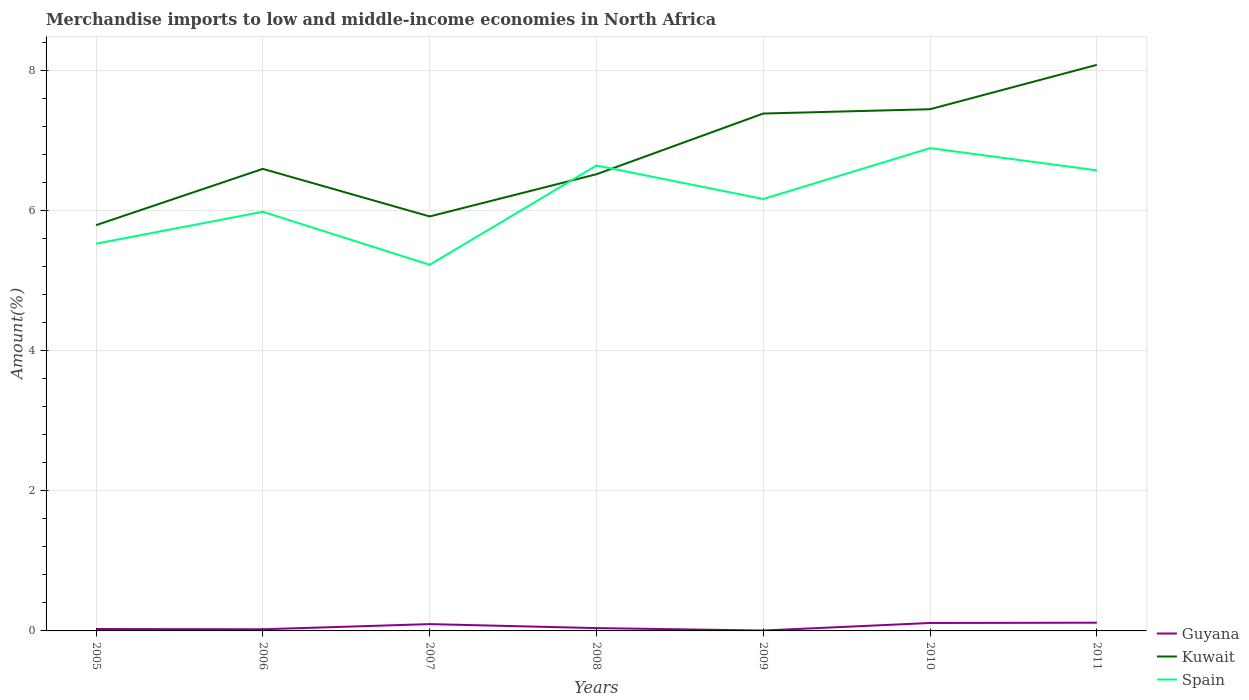How many different coloured lines are there?
Offer a terse response. 3. Does the line corresponding to Spain intersect with the line corresponding to Guyana?
Offer a terse response. No. Is the number of lines equal to the number of legend labels?
Give a very brief answer. Yes. Across all years, what is the maximum percentage of amount earned from merchandise imports in Kuwait?
Provide a succinct answer. 5.79. What is the total percentage of amount earned from merchandise imports in Guyana in the graph?
Ensure brevity in your answer.  0.09. What is the difference between the highest and the second highest percentage of amount earned from merchandise imports in Kuwait?
Make the answer very short. 2.29. Is the percentage of amount earned from merchandise imports in Spain strictly greater than the percentage of amount earned from merchandise imports in Kuwait over the years?
Give a very brief answer. No. How many years are there in the graph?
Your answer should be very brief. 7. Does the graph contain grids?
Ensure brevity in your answer.  Yes. Where does the legend appear in the graph?
Offer a very short reply. Bottom right. How are the legend labels stacked?
Provide a succinct answer. Vertical. What is the title of the graph?
Your answer should be compact. Merchandise imports to low and middle-income economies in North Africa. What is the label or title of the X-axis?
Keep it short and to the point. Years. What is the label or title of the Y-axis?
Offer a terse response. Amount(%). What is the Amount(%) in Guyana in 2005?
Offer a very short reply. 0.03. What is the Amount(%) of Kuwait in 2005?
Give a very brief answer. 5.79. What is the Amount(%) in Spain in 2005?
Offer a very short reply. 5.53. What is the Amount(%) of Guyana in 2006?
Ensure brevity in your answer.  0.02. What is the Amount(%) of Kuwait in 2006?
Your answer should be very brief. 6.6. What is the Amount(%) of Spain in 2006?
Provide a short and direct response. 5.99. What is the Amount(%) of Guyana in 2007?
Ensure brevity in your answer.  0.1. What is the Amount(%) in Kuwait in 2007?
Provide a succinct answer. 5.92. What is the Amount(%) of Spain in 2007?
Give a very brief answer. 5.23. What is the Amount(%) in Guyana in 2008?
Make the answer very short. 0.04. What is the Amount(%) in Kuwait in 2008?
Provide a short and direct response. 6.52. What is the Amount(%) of Spain in 2008?
Give a very brief answer. 6.65. What is the Amount(%) of Guyana in 2009?
Make the answer very short. 0.01. What is the Amount(%) of Kuwait in 2009?
Provide a short and direct response. 7.39. What is the Amount(%) in Spain in 2009?
Your response must be concise. 6.17. What is the Amount(%) in Guyana in 2010?
Make the answer very short. 0.11. What is the Amount(%) in Kuwait in 2010?
Ensure brevity in your answer.  7.45. What is the Amount(%) of Spain in 2010?
Keep it short and to the point. 6.89. What is the Amount(%) in Guyana in 2011?
Keep it short and to the point. 0.12. What is the Amount(%) in Kuwait in 2011?
Give a very brief answer. 8.08. What is the Amount(%) in Spain in 2011?
Make the answer very short. 6.58. Across all years, what is the maximum Amount(%) of Guyana?
Your answer should be compact. 0.12. Across all years, what is the maximum Amount(%) in Kuwait?
Your answer should be compact. 8.08. Across all years, what is the maximum Amount(%) of Spain?
Your answer should be very brief. 6.89. Across all years, what is the minimum Amount(%) of Guyana?
Your response must be concise. 0.01. Across all years, what is the minimum Amount(%) in Kuwait?
Offer a terse response. 5.79. Across all years, what is the minimum Amount(%) in Spain?
Provide a short and direct response. 5.23. What is the total Amount(%) in Guyana in the graph?
Your answer should be compact. 0.43. What is the total Amount(%) of Kuwait in the graph?
Provide a short and direct response. 47.76. What is the total Amount(%) of Spain in the graph?
Your response must be concise. 43.03. What is the difference between the Amount(%) of Guyana in 2005 and that in 2006?
Keep it short and to the point. 0. What is the difference between the Amount(%) of Kuwait in 2005 and that in 2006?
Offer a terse response. -0.8. What is the difference between the Amount(%) of Spain in 2005 and that in 2006?
Provide a short and direct response. -0.46. What is the difference between the Amount(%) of Guyana in 2005 and that in 2007?
Give a very brief answer. -0.07. What is the difference between the Amount(%) of Kuwait in 2005 and that in 2007?
Give a very brief answer. -0.12. What is the difference between the Amount(%) of Spain in 2005 and that in 2007?
Your answer should be very brief. 0.3. What is the difference between the Amount(%) of Guyana in 2005 and that in 2008?
Your answer should be very brief. -0.01. What is the difference between the Amount(%) in Kuwait in 2005 and that in 2008?
Your answer should be compact. -0.73. What is the difference between the Amount(%) of Spain in 2005 and that in 2008?
Make the answer very short. -1.12. What is the difference between the Amount(%) of Guyana in 2005 and that in 2009?
Provide a short and direct response. 0.02. What is the difference between the Amount(%) in Kuwait in 2005 and that in 2009?
Your answer should be very brief. -1.59. What is the difference between the Amount(%) in Spain in 2005 and that in 2009?
Ensure brevity in your answer.  -0.64. What is the difference between the Amount(%) in Guyana in 2005 and that in 2010?
Make the answer very short. -0.09. What is the difference between the Amount(%) of Kuwait in 2005 and that in 2010?
Keep it short and to the point. -1.66. What is the difference between the Amount(%) in Spain in 2005 and that in 2010?
Provide a short and direct response. -1.36. What is the difference between the Amount(%) of Guyana in 2005 and that in 2011?
Ensure brevity in your answer.  -0.09. What is the difference between the Amount(%) of Kuwait in 2005 and that in 2011?
Provide a succinct answer. -2.29. What is the difference between the Amount(%) of Spain in 2005 and that in 2011?
Provide a short and direct response. -1.05. What is the difference between the Amount(%) of Guyana in 2006 and that in 2007?
Keep it short and to the point. -0.07. What is the difference between the Amount(%) of Kuwait in 2006 and that in 2007?
Provide a short and direct response. 0.68. What is the difference between the Amount(%) of Spain in 2006 and that in 2007?
Offer a very short reply. 0.76. What is the difference between the Amount(%) of Guyana in 2006 and that in 2008?
Offer a terse response. -0.02. What is the difference between the Amount(%) of Kuwait in 2006 and that in 2008?
Offer a very short reply. 0.08. What is the difference between the Amount(%) in Spain in 2006 and that in 2008?
Make the answer very short. -0.66. What is the difference between the Amount(%) of Guyana in 2006 and that in 2009?
Provide a short and direct response. 0.02. What is the difference between the Amount(%) of Kuwait in 2006 and that in 2009?
Your answer should be compact. -0.79. What is the difference between the Amount(%) in Spain in 2006 and that in 2009?
Make the answer very short. -0.18. What is the difference between the Amount(%) in Guyana in 2006 and that in 2010?
Make the answer very short. -0.09. What is the difference between the Amount(%) in Kuwait in 2006 and that in 2010?
Your answer should be compact. -0.85. What is the difference between the Amount(%) of Spain in 2006 and that in 2010?
Your answer should be compact. -0.91. What is the difference between the Amount(%) of Guyana in 2006 and that in 2011?
Give a very brief answer. -0.09. What is the difference between the Amount(%) in Kuwait in 2006 and that in 2011?
Your answer should be very brief. -1.49. What is the difference between the Amount(%) of Spain in 2006 and that in 2011?
Offer a very short reply. -0.59. What is the difference between the Amount(%) in Guyana in 2007 and that in 2008?
Give a very brief answer. 0.06. What is the difference between the Amount(%) of Kuwait in 2007 and that in 2008?
Make the answer very short. -0.6. What is the difference between the Amount(%) of Spain in 2007 and that in 2008?
Offer a very short reply. -1.42. What is the difference between the Amount(%) of Guyana in 2007 and that in 2009?
Provide a succinct answer. 0.09. What is the difference between the Amount(%) in Kuwait in 2007 and that in 2009?
Offer a terse response. -1.47. What is the difference between the Amount(%) in Spain in 2007 and that in 2009?
Offer a terse response. -0.94. What is the difference between the Amount(%) of Guyana in 2007 and that in 2010?
Offer a very short reply. -0.02. What is the difference between the Amount(%) in Kuwait in 2007 and that in 2010?
Your answer should be very brief. -1.53. What is the difference between the Amount(%) in Spain in 2007 and that in 2010?
Keep it short and to the point. -1.67. What is the difference between the Amount(%) in Guyana in 2007 and that in 2011?
Your answer should be very brief. -0.02. What is the difference between the Amount(%) of Kuwait in 2007 and that in 2011?
Ensure brevity in your answer.  -2.16. What is the difference between the Amount(%) of Spain in 2007 and that in 2011?
Provide a short and direct response. -1.35. What is the difference between the Amount(%) of Guyana in 2008 and that in 2009?
Provide a succinct answer. 0.03. What is the difference between the Amount(%) in Kuwait in 2008 and that in 2009?
Ensure brevity in your answer.  -0.87. What is the difference between the Amount(%) of Spain in 2008 and that in 2009?
Give a very brief answer. 0.48. What is the difference between the Amount(%) in Guyana in 2008 and that in 2010?
Give a very brief answer. -0.07. What is the difference between the Amount(%) in Kuwait in 2008 and that in 2010?
Provide a succinct answer. -0.93. What is the difference between the Amount(%) in Spain in 2008 and that in 2010?
Your answer should be very brief. -0.25. What is the difference between the Amount(%) in Guyana in 2008 and that in 2011?
Provide a short and direct response. -0.08. What is the difference between the Amount(%) in Kuwait in 2008 and that in 2011?
Provide a succinct answer. -1.56. What is the difference between the Amount(%) of Spain in 2008 and that in 2011?
Keep it short and to the point. 0.07. What is the difference between the Amount(%) in Guyana in 2009 and that in 2010?
Give a very brief answer. -0.11. What is the difference between the Amount(%) in Kuwait in 2009 and that in 2010?
Your answer should be very brief. -0.06. What is the difference between the Amount(%) in Spain in 2009 and that in 2010?
Your answer should be very brief. -0.73. What is the difference between the Amount(%) in Guyana in 2009 and that in 2011?
Make the answer very short. -0.11. What is the difference between the Amount(%) of Kuwait in 2009 and that in 2011?
Make the answer very short. -0.7. What is the difference between the Amount(%) of Spain in 2009 and that in 2011?
Provide a short and direct response. -0.41. What is the difference between the Amount(%) in Guyana in 2010 and that in 2011?
Your response must be concise. -0. What is the difference between the Amount(%) in Kuwait in 2010 and that in 2011?
Ensure brevity in your answer.  -0.63. What is the difference between the Amount(%) in Spain in 2010 and that in 2011?
Provide a succinct answer. 0.32. What is the difference between the Amount(%) in Guyana in 2005 and the Amount(%) in Kuwait in 2006?
Ensure brevity in your answer.  -6.57. What is the difference between the Amount(%) in Guyana in 2005 and the Amount(%) in Spain in 2006?
Keep it short and to the point. -5.96. What is the difference between the Amount(%) in Kuwait in 2005 and the Amount(%) in Spain in 2006?
Your answer should be very brief. -0.19. What is the difference between the Amount(%) of Guyana in 2005 and the Amount(%) of Kuwait in 2007?
Keep it short and to the point. -5.89. What is the difference between the Amount(%) of Guyana in 2005 and the Amount(%) of Spain in 2007?
Your answer should be compact. -5.2. What is the difference between the Amount(%) of Kuwait in 2005 and the Amount(%) of Spain in 2007?
Keep it short and to the point. 0.57. What is the difference between the Amount(%) of Guyana in 2005 and the Amount(%) of Kuwait in 2008?
Keep it short and to the point. -6.49. What is the difference between the Amount(%) in Guyana in 2005 and the Amount(%) in Spain in 2008?
Give a very brief answer. -6.62. What is the difference between the Amount(%) in Kuwait in 2005 and the Amount(%) in Spain in 2008?
Offer a very short reply. -0.85. What is the difference between the Amount(%) of Guyana in 2005 and the Amount(%) of Kuwait in 2009?
Keep it short and to the point. -7.36. What is the difference between the Amount(%) of Guyana in 2005 and the Amount(%) of Spain in 2009?
Make the answer very short. -6.14. What is the difference between the Amount(%) of Kuwait in 2005 and the Amount(%) of Spain in 2009?
Offer a very short reply. -0.37. What is the difference between the Amount(%) in Guyana in 2005 and the Amount(%) in Kuwait in 2010?
Keep it short and to the point. -7.42. What is the difference between the Amount(%) of Guyana in 2005 and the Amount(%) of Spain in 2010?
Offer a very short reply. -6.87. What is the difference between the Amount(%) of Kuwait in 2005 and the Amount(%) of Spain in 2010?
Offer a terse response. -1.1. What is the difference between the Amount(%) in Guyana in 2005 and the Amount(%) in Kuwait in 2011?
Give a very brief answer. -8.06. What is the difference between the Amount(%) of Guyana in 2005 and the Amount(%) of Spain in 2011?
Your answer should be very brief. -6.55. What is the difference between the Amount(%) of Kuwait in 2005 and the Amount(%) of Spain in 2011?
Keep it short and to the point. -0.78. What is the difference between the Amount(%) in Guyana in 2006 and the Amount(%) in Kuwait in 2007?
Keep it short and to the point. -5.9. What is the difference between the Amount(%) in Guyana in 2006 and the Amount(%) in Spain in 2007?
Keep it short and to the point. -5.21. What is the difference between the Amount(%) in Kuwait in 2006 and the Amount(%) in Spain in 2007?
Offer a terse response. 1.37. What is the difference between the Amount(%) in Guyana in 2006 and the Amount(%) in Kuwait in 2008?
Give a very brief answer. -6.5. What is the difference between the Amount(%) in Guyana in 2006 and the Amount(%) in Spain in 2008?
Provide a succinct answer. -6.62. What is the difference between the Amount(%) in Kuwait in 2006 and the Amount(%) in Spain in 2008?
Give a very brief answer. -0.05. What is the difference between the Amount(%) of Guyana in 2006 and the Amount(%) of Kuwait in 2009?
Provide a short and direct response. -7.37. What is the difference between the Amount(%) of Guyana in 2006 and the Amount(%) of Spain in 2009?
Offer a very short reply. -6.14. What is the difference between the Amount(%) in Kuwait in 2006 and the Amount(%) in Spain in 2009?
Offer a terse response. 0.43. What is the difference between the Amount(%) in Guyana in 2006 and the Amount(%) in Kuwait in 2010?
Your answer should be very brief. -7.43. What is the difference between the Amount(%) in Guyana in 2006 and the Amount(%) in Spain in 2010?
Your response must be concise. -6.87. What is the difference between the Amount(%) of Kuwait in 2006 and the Amount(%) of Spain in 2010?
Your response must be concise. -0.3. What is the difference between the Amount(%) in Guyana in 2006 and the Amount(%) in Kuwait in 2011?
Provide a succinct answer. -8.06. What is the difference between the Amount(%) of Guyana in 2006 and the Amount(%) of Spain in 2011?
Provide a short and direct response. -6.55. What is the difference between the Amount(%) in Kuwait in 2006 and the Amount(%) in Spain in 2011?
Keep it short and to the point. 0.02. What is the difference between the Amount(%) of Guyana in 2007 and the Amount(%) of Kuwait in 2008?
Offer a very short reply. -6.42. What is the difference between the Amount(%) in Guyana in 2007 and the Amount(%) in Spain in 2008?
Your answer should be compact. -6.55. What is the difference between the Amount(%) in Kuwait in 2007 and the Amount(%) in Spain in 2008?
Your answer should be compact. -0.73. What is the difference between the Amount(%) of Guyana in 2007 and the Amount(%) of Kuwait in 2009?
Keep it short and to the point. -7.29. What is the difference between the Amount(%) in Guyana in 2007 and the Amount(%) in Spain in 2009?
Provide a succinct answer. -6.07. What is the difference between the Amount(%) in Kuwait in 2007 and the Amount(%) in Spain in 2009?
Your response must be concise. -0.25. What is the difference between the Amount(%) of Guyana in 2007 and the Amount(%) of Kuwait in 2010?
Your response must be concise. -7.35. What is the difference between the Amount(%) of Guyana in 2007 and the Amount(%) of Spain in 2010?
Keep it short and to the point. -6.8. What is the difference between the Amount(%) of Kuwait in 2007 and the Amount(%) of Spain in 2010?
Ensure brevity in your answer.  -0.98. What is the difference between the Amount(%) of Guyana in 2007 and the Amount(%) of Kuwait in 2011?
Ensure brevity in your answer.  -7.99. What is the difference between the Amount(%) in Guyana in 2007 and the Amount(%) in Spain in 2011?
Make the answer very short. -6.48. What is the difference between the Amount(%) of Kuwait in 2007 and the Amount(%) of Spain in 2011?
Ensure brevity in your answer.  -0.66. What is the difference between the Amount(%) of Guyana in 2008 and the Amount(%) of Kuwait in 2009?
Offer a very short reply. -7.35. What is the difference between the Amount(%) of Guyana in 2008 and the Amount(%) of Spain in 2009?
Offer a terse response. -6.13. What is the difference between the Amount(%) in Kuwait in 2008 and the Amount(%) in Spain in 2009?
Give a very brief answer. 0.35. What is the difference between the Amount(%) in Guyana in 2008 and the Amount(%) in Kuwait in 2010?
Provide a short and direct response. -7.41. What is the difference between the Amount(%) in Guyana in 2008 and the Amount(%) in Spain in 2010?
Offer a very short reply. -6.85. What is the difference between the Amount(%) in Kuwait in 2008 and the Amount(%) in Spain in 2010?
Keep it short and to the point. -0.37. What is the difference between the Amount(%) of Guyana in 2008 and the Amount(%) of Kuwait in 2011?
Your answer should be very brief. -8.04. What is the difference between the Amount(%) in Guyana in 2008 and the Amount(%) in Spain in 2011?
Give a very brief answer. -6.54. What is the difference between the Amount(%) in Kuwait in 2008 and the Amount(%) in Spain in 2011?
Offer a terse response. -0.06. What is the difference between the Amount(%) of Guyana in 2009 and the Amount(%) of Kuwait in 2010?
Make the answer very short. -7.44. What is the difference between the Amount(%) in Guyana in 2009 and the Amount(%) in Spain in 2010?
Offer a terse response. -6.89. What is the difference between the Amount(%) in Kuwait in 2009 and the Amount(%) in Spain in 2010?
Your response must be concise. 0.49. What is the difference between the Amount(%) of Guyana in 2009 and the Amount(%) of Kuwait in 2011?
Provide a succinct answer. -8.08. What is the difference between the Amount(%) in Guyana in 2009 and the Amount(%) in Spain in 2011?
Your response must be concise. -6.57. What is the difference between the Amount(%) of Kuwait in 2009 and the Amount(%) of Spain in 2011?
Keep it short and to the point. 0.81. What is the difference between the Amount(%) of Guyana in 2010 and the Amount(%) of Kuwait in 2011?
Ensure brevity in your answer.  -7.97. What is the difference between the Amount(%) of Guyana in 2010 and the Amount(%) of Spain in 2011?
Ensure brevity in your answer.  -6.46. What is the difference between the Amount(%) in Kuwait in 2010 and the Amount(%) in Spain in 2011?
Provide a succinct answer. 0.87. What is the average Amount(%) of Guyana per year?
Make the answer very short. 0.06. What is the average Amount(%) in Kuwait per year?
Ensure brevity in your answer.  6.82. What is the average Amount(%) of Spain per year?
Make the answer very short. 6.15. In the year 2005, what is the difference between the Amount(%) of Guyana and Amount(%) of Kuwait?
Provide a short and direct response. -5.77. In the year 2005, what is the difference between the Amount(%) in Guyana and Amount(%) in Spain?
Make the answer very short. -5.5. In the year 2005, what is the difference between the Amount(%) of Kuwait and Amount(%) of Spain?
Your answer should be very brief. 0.26. In the year 2006, what is the difference between the Amount(%) of Guyana and Amount(%) of Kuwait?
Your answer should be compact. -6.58. In the year 2006, what is the difference between the Amount(%) in Guyana and Amount(%) in Spain?
Offer a very short reply. -5.96. In the year 2006, what is the difference between the Amount(%) in Kuwait and Amount(%) in Spain?
Make the answer very short. 0.61. In the year 2007, what is the difference between the Amount(%) of Guyana and Amount(%) of Kuwait?
Offer a terse response. -5.82. In the year 2007, what is the difference between the Amount(%) of Guyana and Amount(%) of Spain?
Make the answer very short. -5.13. In the year 2007, what is the difference between the Amount(%) of Kuwait and Amount(%) of Spain?
Offer a terse response. 0.69. In the year 2008, what is the difference between the Amount(%) of Guyana and Amount(%) of Kuwait?
Keep it short and to the point. -6.48. In the year 2008, what is the difference between the Amount(%) in Guyana and Amount(%) in Spain?
Make the answer very short. -6.61. In the year 2008, what is the difference between the Amount(%) of Kuwait and Amount(%) of Spain?
Your response must be concise. -0.12. In the year 2009, what is the difference between the Amount(%) in Guyana and Amount(%) in Kuwait?
Your answer should be very brief. -7.38. In the year 2009, what is the difference between the Amount(%) of Guyana and Amount(%) of Spain?
Give a very brief answer. -6.16. In the year 2009, what is the difference between the Amount(%) of Kuwait and Amount(%) of Spain?
Your answer should be compact. 1.22. In the year 2010, what is the difference between the Amount(%) in Guyana and Amount(%) in Kuwait?
Keep it short and to the point. -7.34. In the year 2010, what is the difference between the Amount(%) of Guyana and Amount(%) of Spain?
Your answer should be compact. -6.78. In the year 2010, what is the difference between the Amount(%) in Kuwait and Amount(%) in Spain?
Provide a succinct answer. 0.56. In the year 2011, what is the difference between the Amount(%) in Guyana and Amount(%) in Kuwait?
Ensure brevity in your answer.  -7.97. In the year 2011, what is the difference between the Amount(%) of Guyana and Amount(%) of Spain?
Ensure brevity in your answer.  -6.46. In the year 2011, what is the difference between the Amount(%) in Kuwait and Amount(%) in Spain?
Make the answer very short. 1.51. What is the ratio of the Amount(%) in Guyana in 2005 to that in 2006?
Give a very brief answer. 1.17. What is the ratio of the Amount(%) of Kuwait in 2005 to that in 2006?
Offer a very short reply. 0.88. What is the ratio of the Amount(%) of Spain in 2005 to that in 2006?
Offer a terse response. 0.92. What is the ratio of the Amount(%) in Guyana in 2005 to that in 2007?
Ensure brevity in your answer.  0.28. What is the ratio of the Amount(%) in Spain in 2005 to that in 2007?
Give a very brief answer. 1.06. What is the ratio of the Amount(%) in Guyana in 2005 to that in 2008?
Provide a short and direct response. 0.68. What is the ratio of the Amount(%) in Kuwait in 2005 to that in 2008?
Your response must be concise. 0.89. What is the ratio of the Amount(%) of Spain in 2005 to that in 2008?
Your answer should be compact. 0.83. What is the ratio of the Amount(%) of Guyana in 2005 to that in 2009?
Offer a terse response. 4.84. What is the ratio of the Amount(%) of Kuwait in 2005 to that in 2009?
Provide a short and direct response. 0.78. What is the ratio of the Amount(%) in Spain in 2005 to that in 2009?
Keep it short and to the point. 0.9. What is the ratio of the Amount(%) in Guyana in 2005 to that in 2010?
Your response must be concise. 0.24. What is the ratio of the Amount(%) in Kuwait in 2005 to that in 2010?
Give a very brief answer. 0.78. What is the ratio of the Amount(%) of Spain in 2005 to that in 2010?
Offer a very short reply. 0.8. What is the ratio of the Amount(%) in Guyana in 2005 to that in 2011?
Your response must be concise. 0.23. What is the ratio of the Amount(%) of Kuwait in 2005 to that in 2011?
Offer a terse response. 0.72. What is the ratio of the Amount(%) in Spain in 2005 to that in 2011?
Provide a short and direct response. 0.84. What is the ratio of the Amount(%) of Guyana in 2006 to that in 2007?
Ensure brevity in your answer.  0.24. What is the ratio of the Amount(%) of Kuwait in 2006 to that in 2007?
Your answer should be compact. 1.11. What is the ratio of the Amount(%) of Spain in 2006 to that in 2007?
Your answer should be very brief. 1.14. What is the ratio of the Amount(%) of Guyana in 2006 to that in 2008?
Make the answer very short. 0.58. What is the ratio of the Amount(%) of Kuwait in 2006 to that in 2008?
Provide a short and direct response. 1.01. What is the ratio of the Amount(%) of Spain in 2006 to that in 2008?
Provide a succinct answer. 0.9. What is the ratio of the Amount(%) of Guyana in 2006 to that in 2009?
Keep it short and to the point. 4.13. What is the ratio of the Amount(%) in Kuwait in 2006 to that in 2009?
Provide a short and direct response. 0.89. What is the ratio of the Amount(%) of Spain in 2006 to that in 2009?
Offer a terse response. 0.97. What is the ratio of the Amount(%) in Guyana in 2006 to that in 2010?
Keep it short and to the point. 0.21. What is the ratio of the Amount(%) in Kuwait in 2006 to that in 2010?
Ensure brevity in your answer.  0.89. What is the ratio of the Amount(%) in Spain in 2006 to that in 2010?
Your answer should be very brief. 0.87. What is the ratio of the Amount(%) of Guyana in 2006 to that in 2011?
Provide a succinct answer. 0.2. What is the ratio of the Amount(%) in Kuwait in 2006 to that in 2011?
Give a very brief answer. 0.82. What is the ratio of the Amount(%) in Spain in 2006 to that in 2011?
Your response must be concise. 0.91. What is the ratio of the Amount(%) in Guyana in 2007 to that in 2008?
Provide a short and direct response. 2.41. What is the ratio of the Amount(%) of Kuwait in 2007 to that in 2008?
Provide a short and direct response. 0.91. What is the ratio of the Amount(%) in Spain in 2007 to that in 2008?
Your answer should be compact. 0.79. What is the ratio of the Amount(%) of Guyana in 2007 to that in 2009?
Offer a very short reply. 17.11. What is the ratio of the Amount(%) of Kuwait in 2007 to that in 2009?
Provide a succinct answer. 0.8. What is the ratio of the Amount(%) of Spain in 2007 to that in 2009?
Keep it short and to the point. 0.85. What is the ratio of the Amount(%) in Guyana in 2007 to that in 2010?
Ensure brevity in your answer.  0.86. What is the ratio of the Amount(%) of Kuwait in 2007 to that in 2010?
Make the answer very short. 0.79. What is the ratio of the Amount(%) of Spain in 2007 to that in 2010?
Your response must be concise. 0.76. What is the ratio of the Amount(%) in Guyana in 2007 to that in 2011?
Offer a terse response. 0.83. What is the ratio of the Amount(%) in Kuwait in 2007 to that in 2011?
Provide a short and direct response. 0.73. What is the ratio of the Amount(%) of Spain in 2007 to that in 2011?
Give a very brief answer. 0.79. What is the ratio of the Amount(%) in Guyana in 2008 to that in 2009?
Ensure brevity in your answer.  7.1. What is the ratio of the Amount(%) of Kuwait in 2008 to that in 2009?
Offer a very short reply. 0.88. What is the ratio of the Amount(%) in Spain in 2008 to that in 2009?
Your answer should be compact. 1.08. What is the ratio of the Amount(%) in Guyana in 2008 to that in 2010?
Offer a very short reply. 0.36. What is the ratio of the Amount(%) of Kuwait in 2008 to that in 2010?
Your response must be concise. 0.88. What is the ratio of the Amount(%) of Spain in 2008 to that in 2010?
Give a very brief answer. 0.96. What is the ratio of the Amount(%) in Guyana in 2008 to that in 2011?
Keep it short and to the point. 0.34. What is the ratio of the Amount(%) in Kuwait in 2008 to that in 2011?
Give a very brief answer. 0.81. What is the ratio of the Amount(%) of Spain in 2008 to that in 2011?
Your response must be concise. 1.01. What is the ratio of the Amount(%) of Guyana in 2009 to that in 2010?
Offer a very short reply. 0.05. What is the ratio of the Amount(%) in Spain in 2009 to that in 2010?
Offer a terse response. 0.89. What is the ratio of the Amount(%) of Guyana in 2009 to that in 2011?
Your answer should be compact. 0.05. What is the ratio of the Amount(%) in Kuwait in 2009 to that in 2011?
Make the answer very short. 0.91. What is the ratio of the Amount(%) of Spain in 2009 to that in 2011?
Offer a terse response. 0.94. What is the ratio of the Amount(%) of Guyana in 2010 to that in 2011?
Offer a very short reply. 0.96. What is the ratio of the Amount(%) in Kuwait in 2010 to that in 2011?
Make the answer very short. 0.92. What is the ratio of the Amount(%) in Spain in 2010 to that in 2011?
Keep it short and to the point. 1.05. What is the difference between the highest and the second highest Amount(%) of Guyana?
Offer a terse response. 0. What is the difference between the highest and the second highest Amount(%) in Kuwait?
Your answer should be very brief. 0.63. What is the difference between the highest and the second highest Amount(%) in Spain?
Your response must be concise. 0.25. What is the difference between the highest and the lowest Amount(%) of Guyana?
Your response must be concise. 0.11. What is the difference between the highest and the lowest Amount(%) of Kuwait?
Your answer should be compact. 2.29. What is the difference between the highest and the lowest Amount(%) of Spain?
Your answer should be compact. 1.67. 